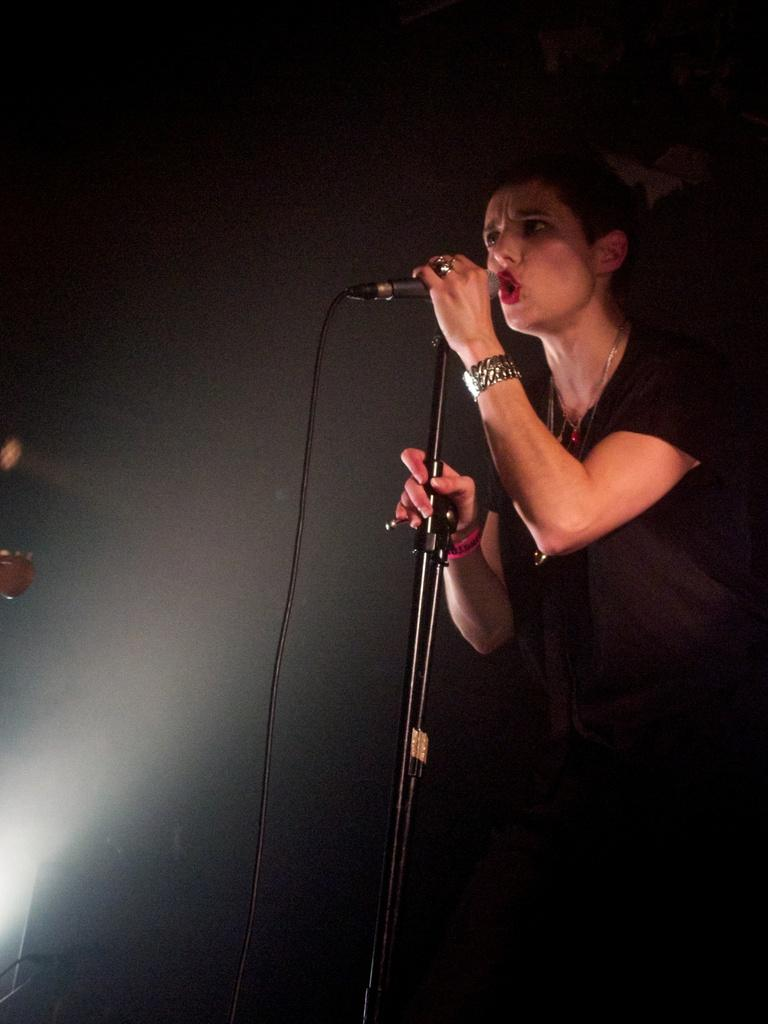What is the overall color scheme of the image? The background of the image is dark. Can you describe the person in the image? There is a person standing in the image, and they are holding a microphone. What is the person doing with their hands? The person is standing with their hands on a stand. What activity is the person engaged in? The person is singing. What type of metal can be seen in the person's hands in the image? There is no metal visible in the person's hands in the image; they are holding a microphone, which is made of plastic or other materials. How many men are present in the image? The image only features one person, and there is no indication of their gender, so we cannot determine if they are a man or not. 